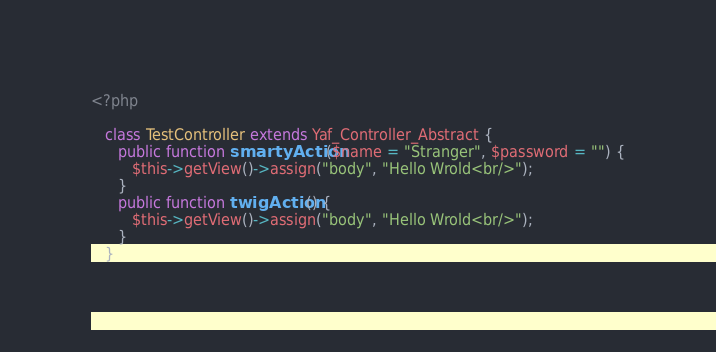<code> <loc_0><loc_0><loc_500><loc_500><_PHP_><?php

   class TestController extends Yaf_Controller_Abstract {
      public function smartyAction($name = "Stranger", $password = "") {
         $this->getView()->assign("body", "Hello Wrold<br/>");
      }
      public function twigAction() {
         $this->getView()->assign("body", "Hello Wrold<br/>");
      }
   }


</code> 